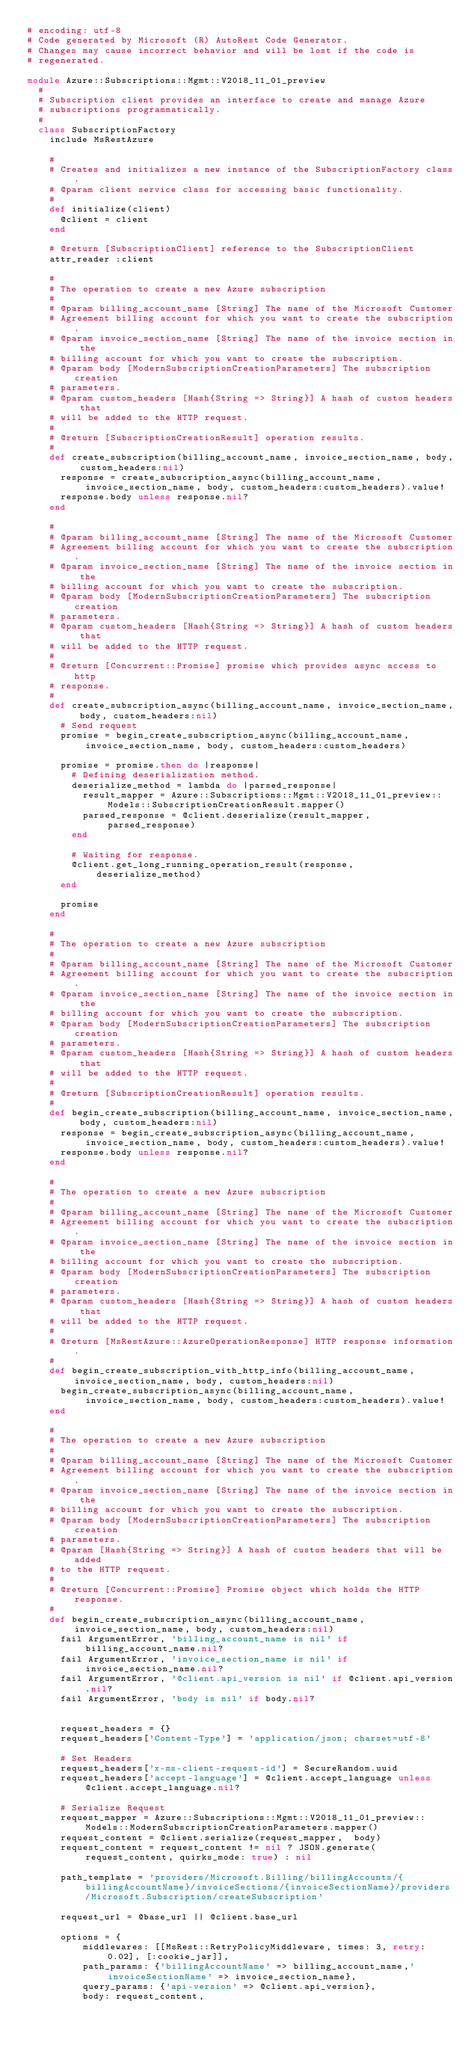<code> <loc_0><loc_0><loc_500><loc_500><_Ruby_># encoding: utf-8
# Code generated by Microsoft (R) AutoRest Code Generator.
# Changes may cause incorrect behavior and will be lost if the code is
# regenerated.

module Azure::Subscriptions::Mgmt::V2018_11_01_preview
  #
  # Subscription client provides an interface to create and manage Azure
  # subscriptions programmatically.
  #
  class SubscriptionFactory
    include MsRestAzure

    #
    # Creates and initializes a new instance of the SubscriptionFactory class.
    # @param client service class for accessing basic functionality.
    #
    def initialize(client)
      @client = client
    end

    # @return [SubscriptionClient] reference to the SubscriptionClient
    attr_reader :client

    #
    # The operation to create a new Azure subscription
    #
    # @param billing_account_name [String] The name of the Microsoft Customer
    # Agreement billing account for which you want to create the subscription.
    # @param invoice_section_name [String] The name of the invoice section in the
    # billing account for which you want to create the subscription.
    # @param body [ModernSubscriptionCreationParameters] The subscription creation
    # parameters.
    # @param custom_headers [Hash{String => String}] A hash of custom headers that
    # will be added to the HTTP request.
    #
    # @return [SubscriptionCreationResult] operation results.
    #
    def create_subscription(billing_account_name, invoice_section_name, body, custom_headers:nil)
      response = create_subscription_async(billing_account_name, invoice_section_name, body, custom_headers:custom_headers).value!
      response.body unless response.nil?
    end

    #
    # @param billing_account_name [String] The name of the Microsoft Customer
    # Agreement billing account for which you want to create the subscription.
    # @param invoice_section_name [String] The name of the invoice section in the
    # billing account for which you want to create the subscription.
    # @param body [ModernSubscriptionCreationParameters] The subscription creation
    # parameters.
    # @param custom_headers [Hash{String => String}] A hash of custom headers that
    # will be added to the HTTP request.
    #
    # @return [Concurrent::Promise] promise which provides async access to http
    # response.
    #
    def create_subscription_async(billing_account_name, invoice_section_name, body, custom_headers:nil)
      # Send request
      promise = begin_create_subscription_async(billing_account_name, invoice_section_name, body, custom_headers:custom_headers)

      promise = promise.then do |response|
        # Defining deserialization method.
        deserialize_method = lambda do |parsed_response|
          result_mapper = Azure::Subscriptions::Mgmt::V2018_11_01_preview::Models::SubscriptionCreationResult.mapper()
          parsed_response = @client.deserialize(result_mapper, parsed_response)
        end

        # Waiting for response.
        @client.get_long_running_operation_result(response, deserialize_method)
      end

      promise
    end

    #
    # The operation to create a new Azure subscription
    #
    # @param billing_account_name [String] The name of the Microsoft Customer
    # Agreement billing account for which you want to create the subscription.
    # @param invoice_section_name [String] The name of the invoice section in the
    # billing account for which you want to create the subscription.
    # @param body [ModernSubscriptionCreationParameters] The subscription creation
    # parameters.
    # @param custom_headers [Hash{String => String}] A hash of custom headers that
    # will be added to the HTTP request.
    #
    # @return [SubscriptionCreationResult] operation results.
    #
    def begin_create_subscription(billing_account_name, invoice_section_name, body, custom_headers:nil)
      response = begin_create_subscription_async(billing_account_name, invoice_section_name, body, custom_headers:custom_headers).value!
      response.body unless response.nil?
    end

    #
    # The operation to create a new Azure subscription
    #
    # @param billing_account_name [String] The name of the Microsoft Customer
    # Agreement billing account for which you want to create the subscription.
    # @param invoice_section_name [String] The name of the invoice section in the
    # billing account for which you want to create the subscription.
    # @param body [ModernSubscriptionCreationParameters] The subscription creation
    # parameters.
    # @param custom_headers [Hash{String => String}] A hash of custom headers that
    # will be added to the HTTP request.
    #
    # @return [MsRestAzure::AzureOperationResponse] HTTP response information.
    #
    def begin_create_subscription_with_http_info(billing_account_name, invoice_section_name, body, custom_headers:nil)
      begin_create_subscription_async(billing_account_name, invoice_section_name, body, custom_headers:custom_headers).value!
    end

    #
    # The operation to create a new Azure subscription
    #
    # @param billing_account_name [String] The name of the Microsoft Customer
    # Agreement billing account for which you want to create the subscription.
    # @param invoice_section_name [String] The name of the invoice section in the
    # billing account for which you want to create the subscription.
    # @param body [ModernSubscriptionCreationParameters] The subscription creation
    # parameters.
    # @param [Hash{String => String}] A hash of custom headers that will be added
    # to the HTTP request.
    #
    # @return [Concurrent::Promise] Promise object which holds the HTTP response.
    #
    def begin_create_subscription_async(billing_account_name, invoice_section_name, body, custom_headers:nil)
      fail ArgumentError, 'billing_account_name is nil' if billing_account_name.nil?
      fail ArgumentError, 'invoice_section_name is nil' if invoice_section_name.nil?
      fail ArgumentError, '@client.api_version is nil' if @client.api_version.nil?
      fail ArgumentError, 'body is nil' if body.nil?


      request_headers = {}
      request_headers['Content-Type'] = 'application/json; charset=utf-8'

      # Set Headers
      request_headers['x-ms-client-request-id'] = SecureRandom.uuid
      request_headers['accept-language'] = @client.accept_language unless @client.accept_language.nil?

      # Serialize Request
      request_mapper = Azure::Subscriptions::Mgmt::V2018_11_01_preview::Models::ModernSubscriptionCreationParameters.mapper()
      request_content = @client.serialize(request_mapper,  body)
      request_content = request_content != nil ? JSON.generate(request_content, quirks_mode: true) : nil

      path_template = 'providers/Microsoft.Billing/billingAccounts/{billingAccountName}/invoiceSections/{invoiceSectionName}/providers/Microsoft.Subscription/createSubscription'

      request_url = @base_url || @client.base_url

      options = {
          middlewares: [[MsRest::RetryPolicyMiddleware, times: 3, retry: 0.02], [:cookie_jar]],
          path_params: {'billingAccountName' => billing_account_name,'invoiceSectionName' => invoice_section_name},
          query_params: {'api-version' => @client.api_version},
          body: request_content,</code> 